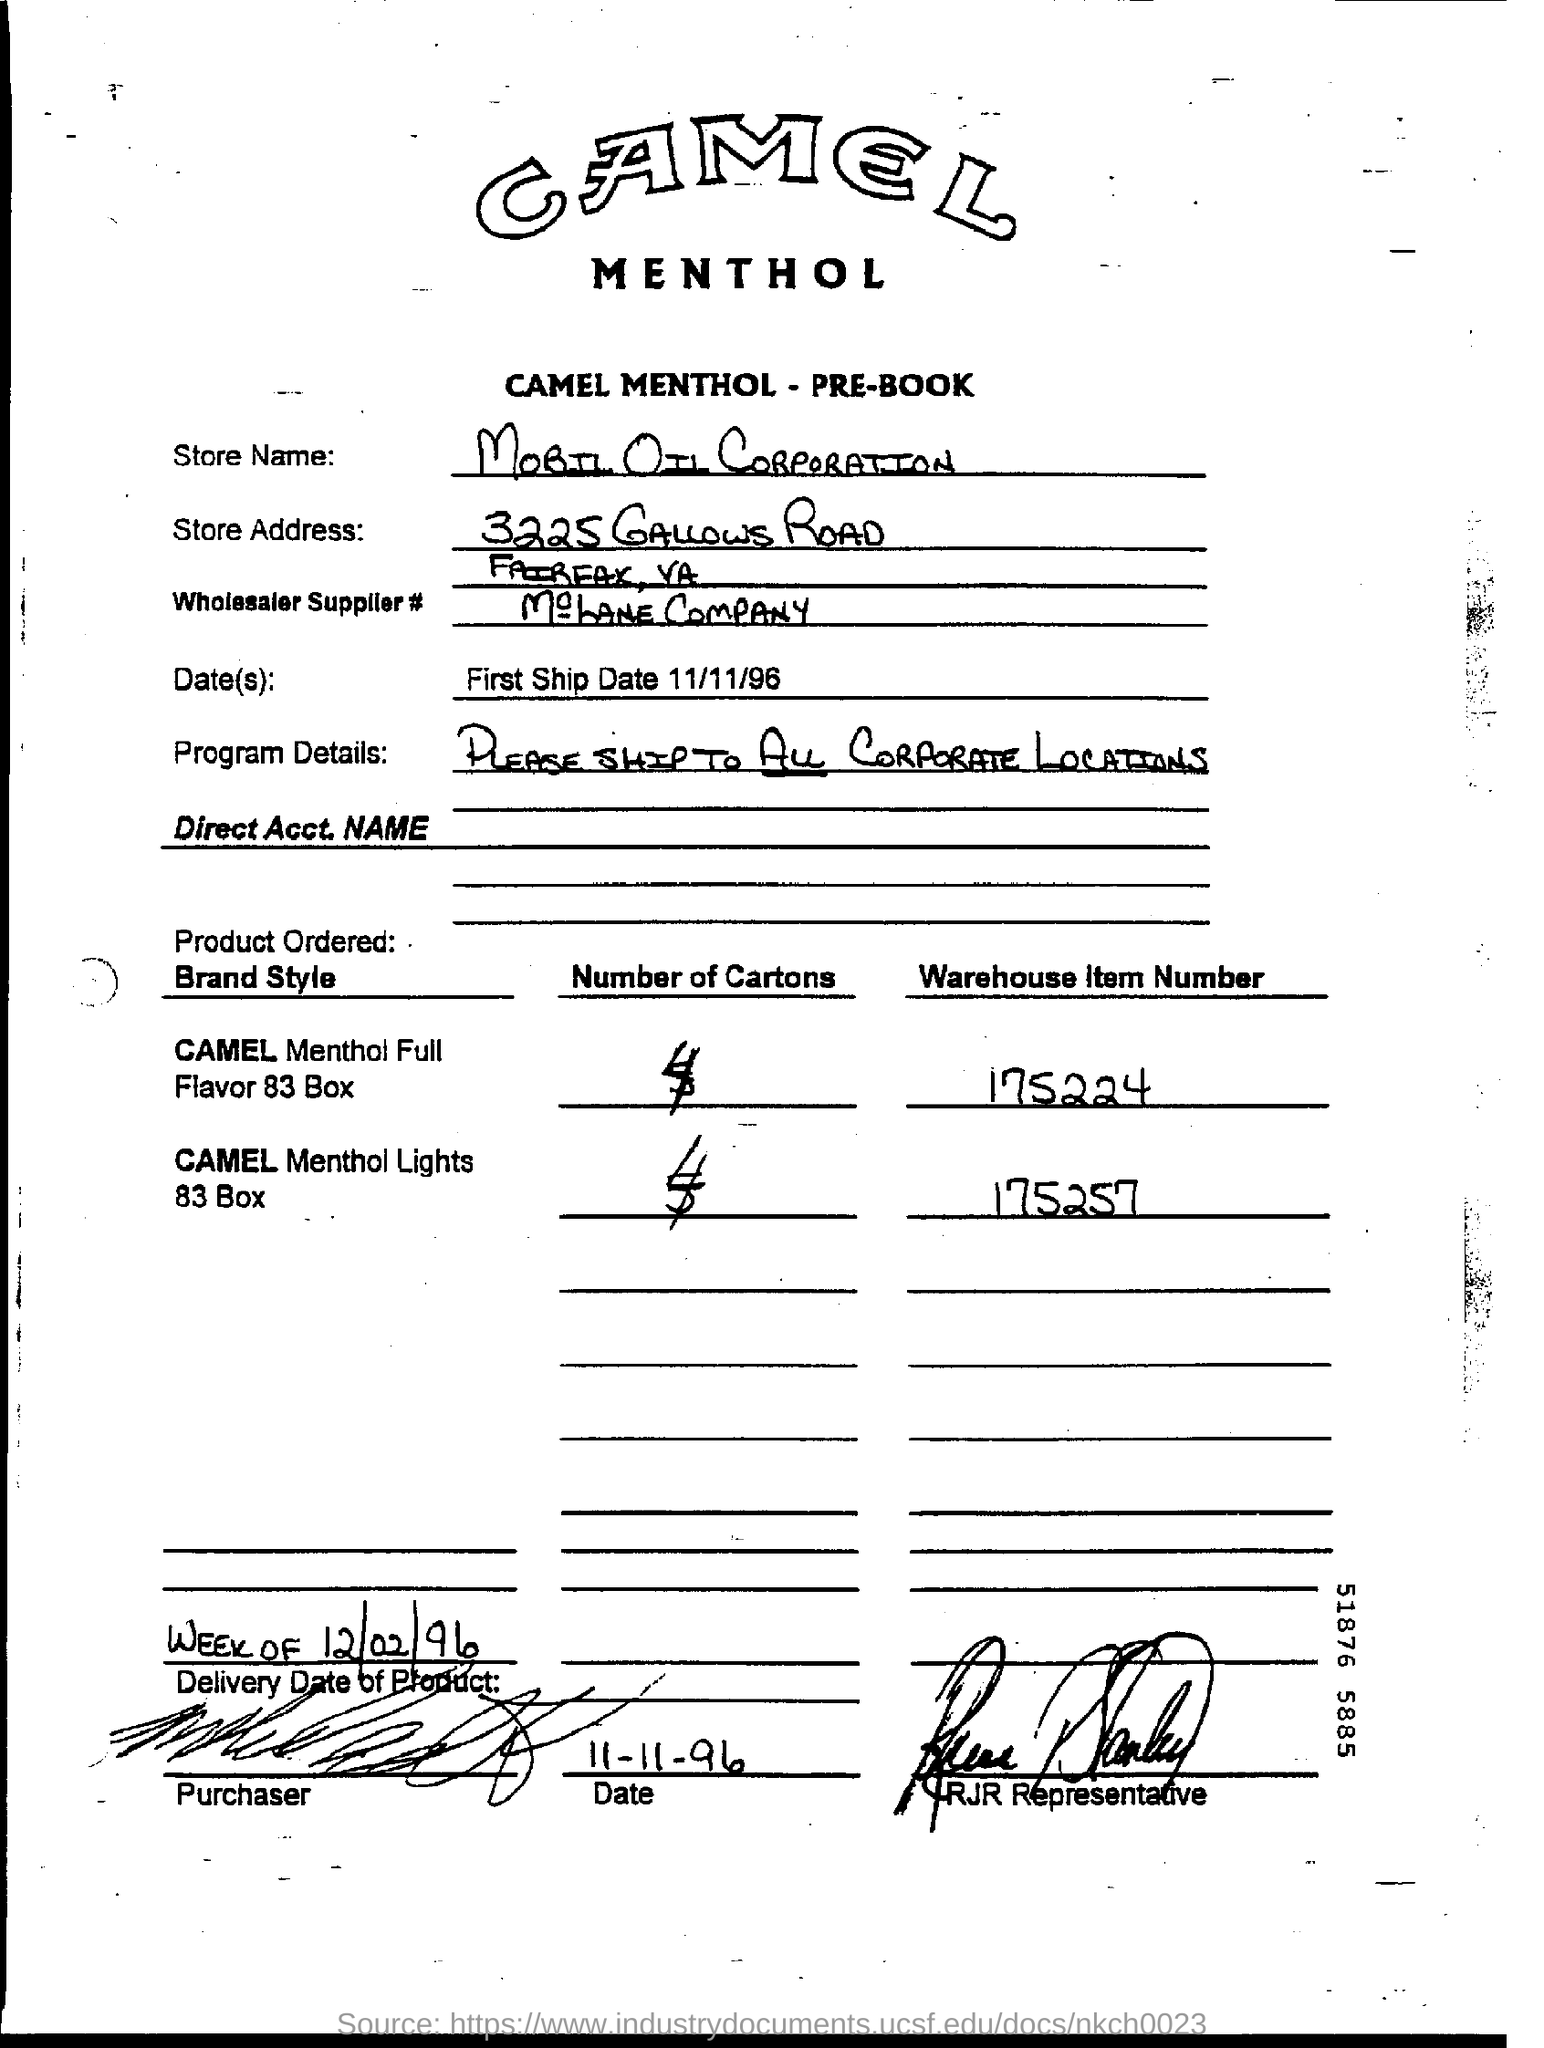Identify some key points in this picture. The document mentions "Mobil Oil Corporation" as the store name. The term "First ship date" refers to the date on which a product was first shipped from the manufacturer or supplier to the customer. 